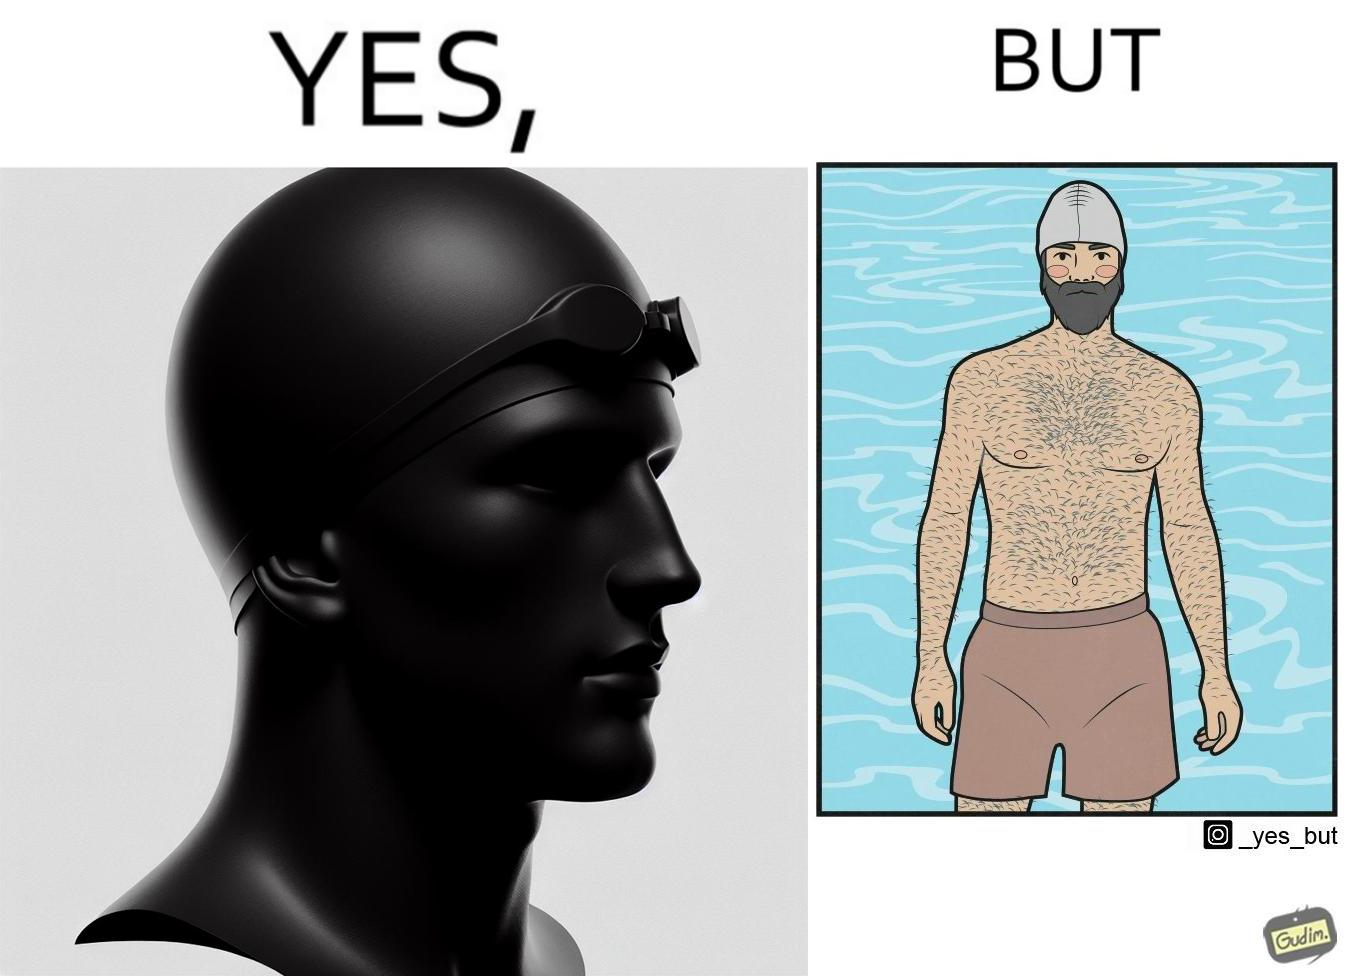Compare the left and right sides of this image. In the left part of the image: a person's face is shown wearing some cap, probably swimming cap In the right part of the image: a person in shorts wearing a swimming cap standing near some water body, having beard and hairs all over his body 